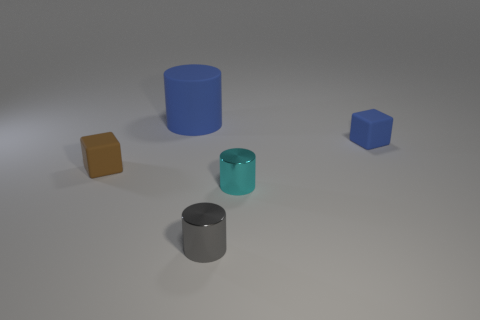Does the brown thing have the same material as the cylinder that is behind the blue cube?
Your answer should be compact. Yes. Are there any small rubber things of the same color as the large matte cylinder?
Provide a short and direct response. Yes. What number of other things are made of the same material as the small gray cylinder?
Your response must be concise. 1. Does the rubber cylinder have the same color as the metallic object to the left of the tiny cyan thing?
Ensure brevity in your answer.  No. Is the number of cyan metallic cylinders that are to the left of the tiny blue matte thing greater than the number of purple balls?
Your response must be concise. Yes. There is a block right of the cube that is on the left side of the big blue object; how many tiny blue rubber things are in front of it?
Provide a short and direct response. 0. There is a tiny rubber object that is behind the tiny brown block; does it have the same shape as the big object?
Offer a very short reply. No. What is the material of the thing behind the tiny blue thing?
Your answer should be very brief. Rubber. There is a matte object that is both left of the gray cylinder and in front of the blue cylinder; what shape is it?
Make the answer very short. Cube. What is the material of the brown object?
Offer a very short reply. Rubber. 